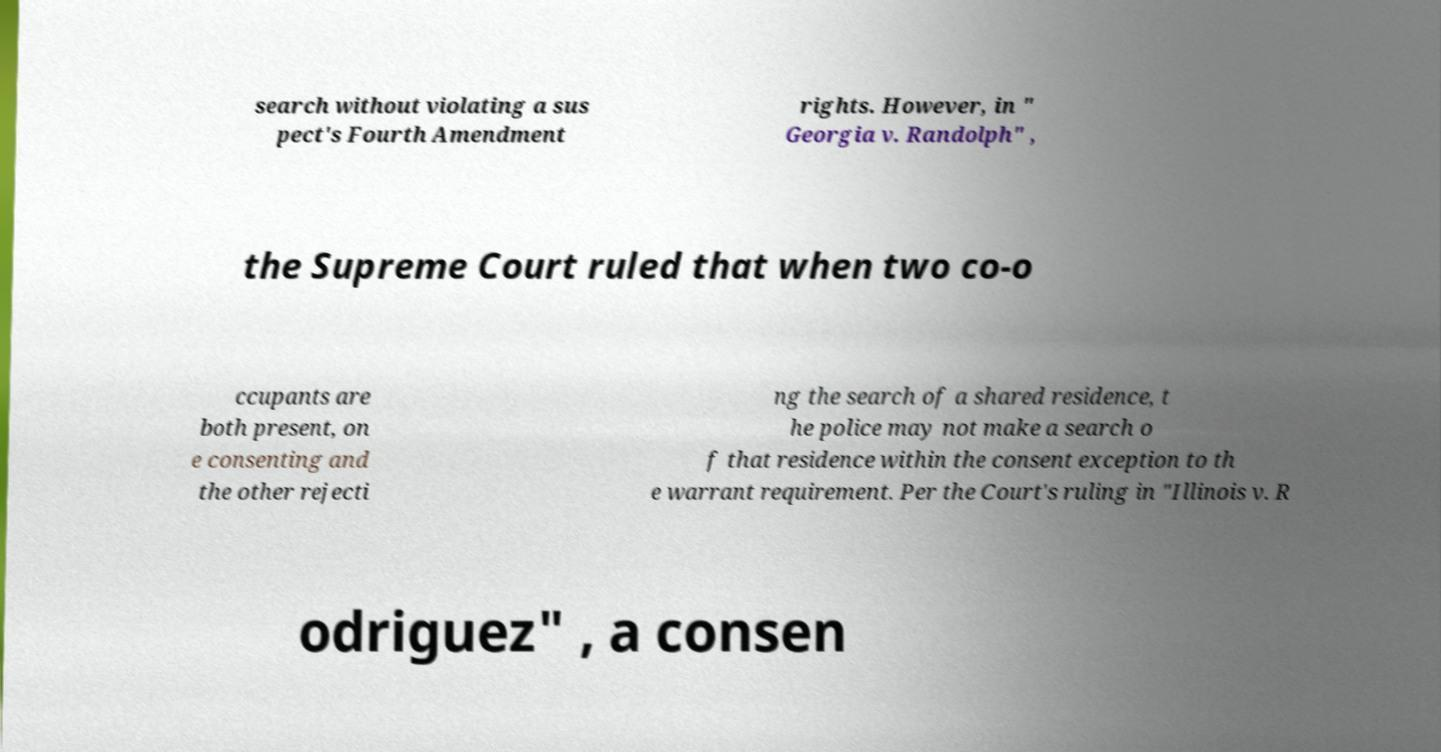For documentation purposes, I need the text within this image transcribed. Could you provide that? search without violating a sus pect's Fourth Amendment rights. However, in " Georgia v. Randolph" , the Supreme Court ruled that when two co-o ccupants are both present, on e consenting and the other rejecti ng the search of a shared residence, t he police may not make a search o f that residence within the consent exception to th e warrant requirement. Per the Court's ruling in "Illinois v. R odriguez" , a consen 